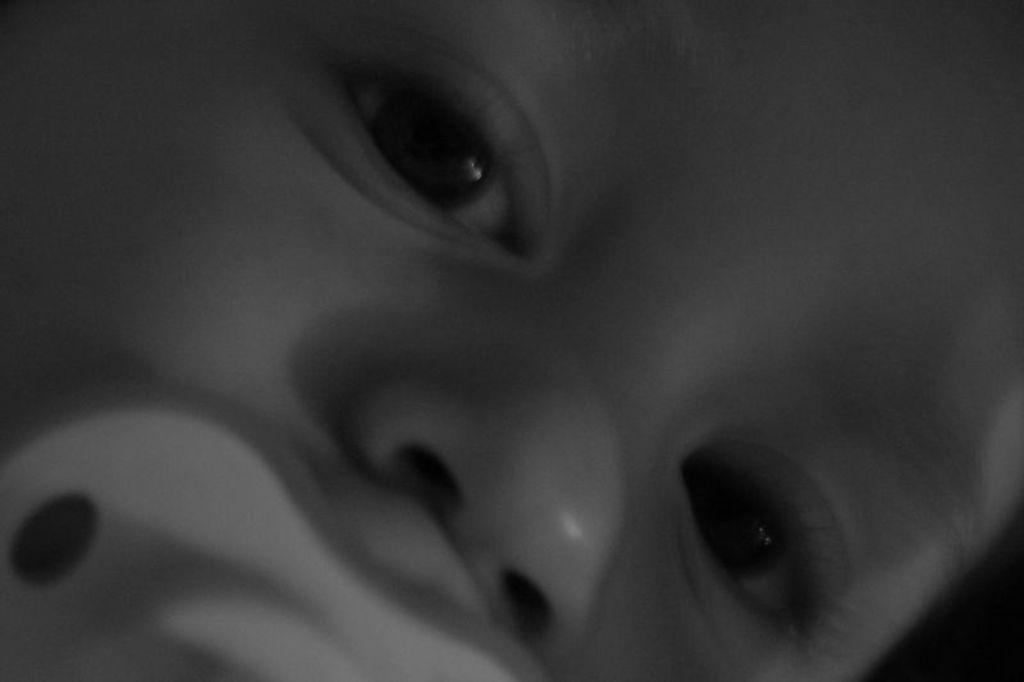Could you give a brief overview of what you see in this image? In this image we can see a face of a child and there is a nipple in his mouth. 